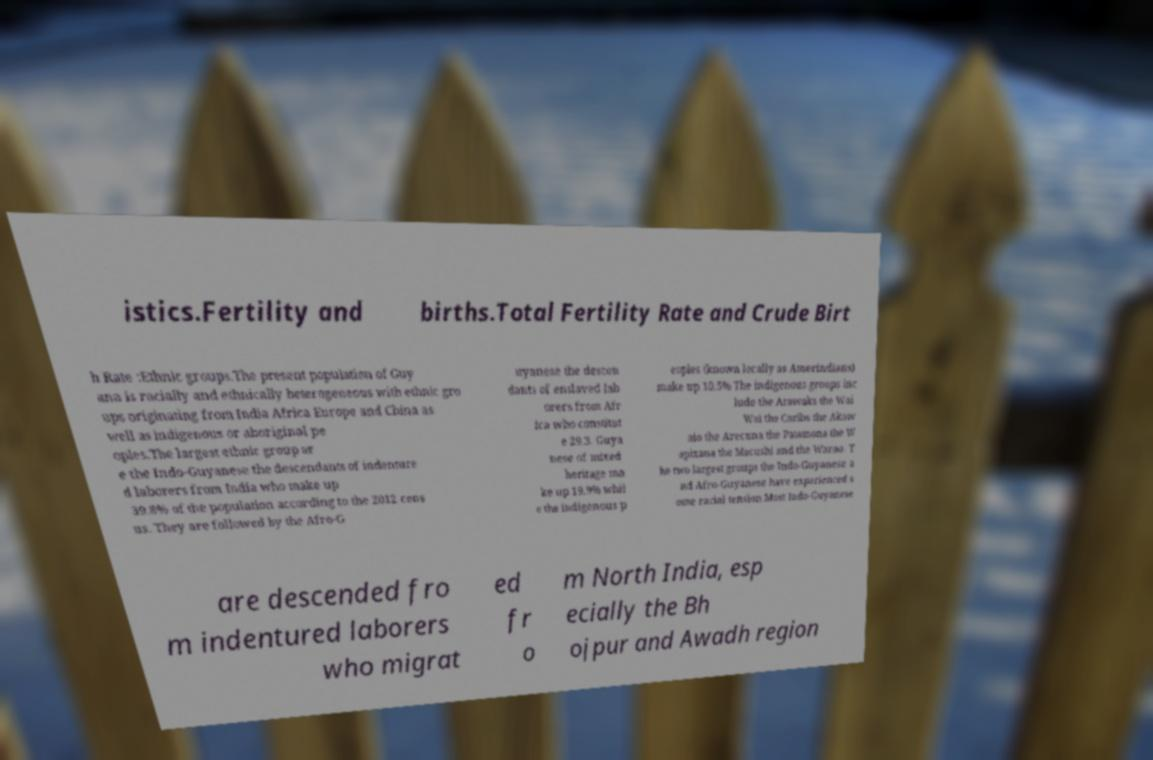What messages or text are displayed in this image? I need them in a readable, typed format. istics.Fertility and births.Total Fertility Rate and Crude Birt h Rate :Ethnic groups.The present population of Guy ana is racially and ethnically heterogeneous with ethnic gro ups originating from India Africa Europe and China as well as indigenous or aboriginal pe oples.The largest ethnic group ar e the Indo-Guyanese the descendants of indenture d laborers from India who make up 39.8% of the population according to the 2012 cens us. They are followed by the Afro-G uyanese the descen dants of enslaved lab orers from Afr ica who constitut e 29.3. Guya nese of mixed heritage ma ke up 19.9% whil e the indigenous p eoples (known locally as Amerindians) make up 10.5% The indigenous groups inc lude the Arawaks the Wai Wai the Caribs the Akaw aio the Arecuna the Patamona the W apixana the Macushi and the Warao. T he two largest groups the Indo-Guyanese a nd Afro-Guyanese have experienced s ome racial tension.Most Indo-Guyanese are descended fro m indentured laborers who migrat ed fr o m North India, esp ecially the Bh ojpur and Awadh region 